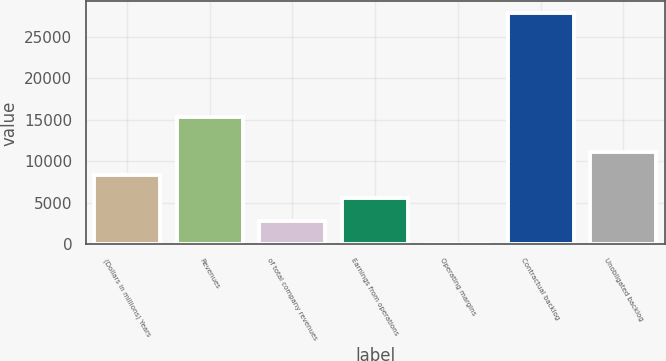<chart> <loc_0><loc_0><loc_500><loc_500><bar_chart><fcel>(Dollars in millions) Years<fcel>Revenues<fcel>of total company revenues<fcel>Earnings from operations<fcel>Operating margins<fcel>Contractual backlog<fcel>Unobligated backlog<nl><fcel>8376.19<fcel>15388<fcel>2798.53<fcel>5587.36<fcel>9.7<fcel>27898<fcel>11165<nl></chart> 